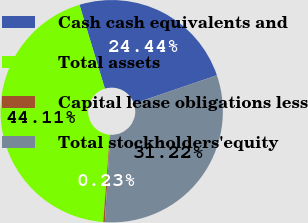Convert chart to OTSL. <chart><loc_0><loc_0><loc_500><loc_500><pie_chart><fcel>Cash cash equivalents and<fcel>Total assets<fcel>Capital lease obligations less<fcel>Total stockholders'equity<nl><fcel>24.44%<fcel>44.11%<fcel>0.23%<fcel>31.22%<nl></chart> 